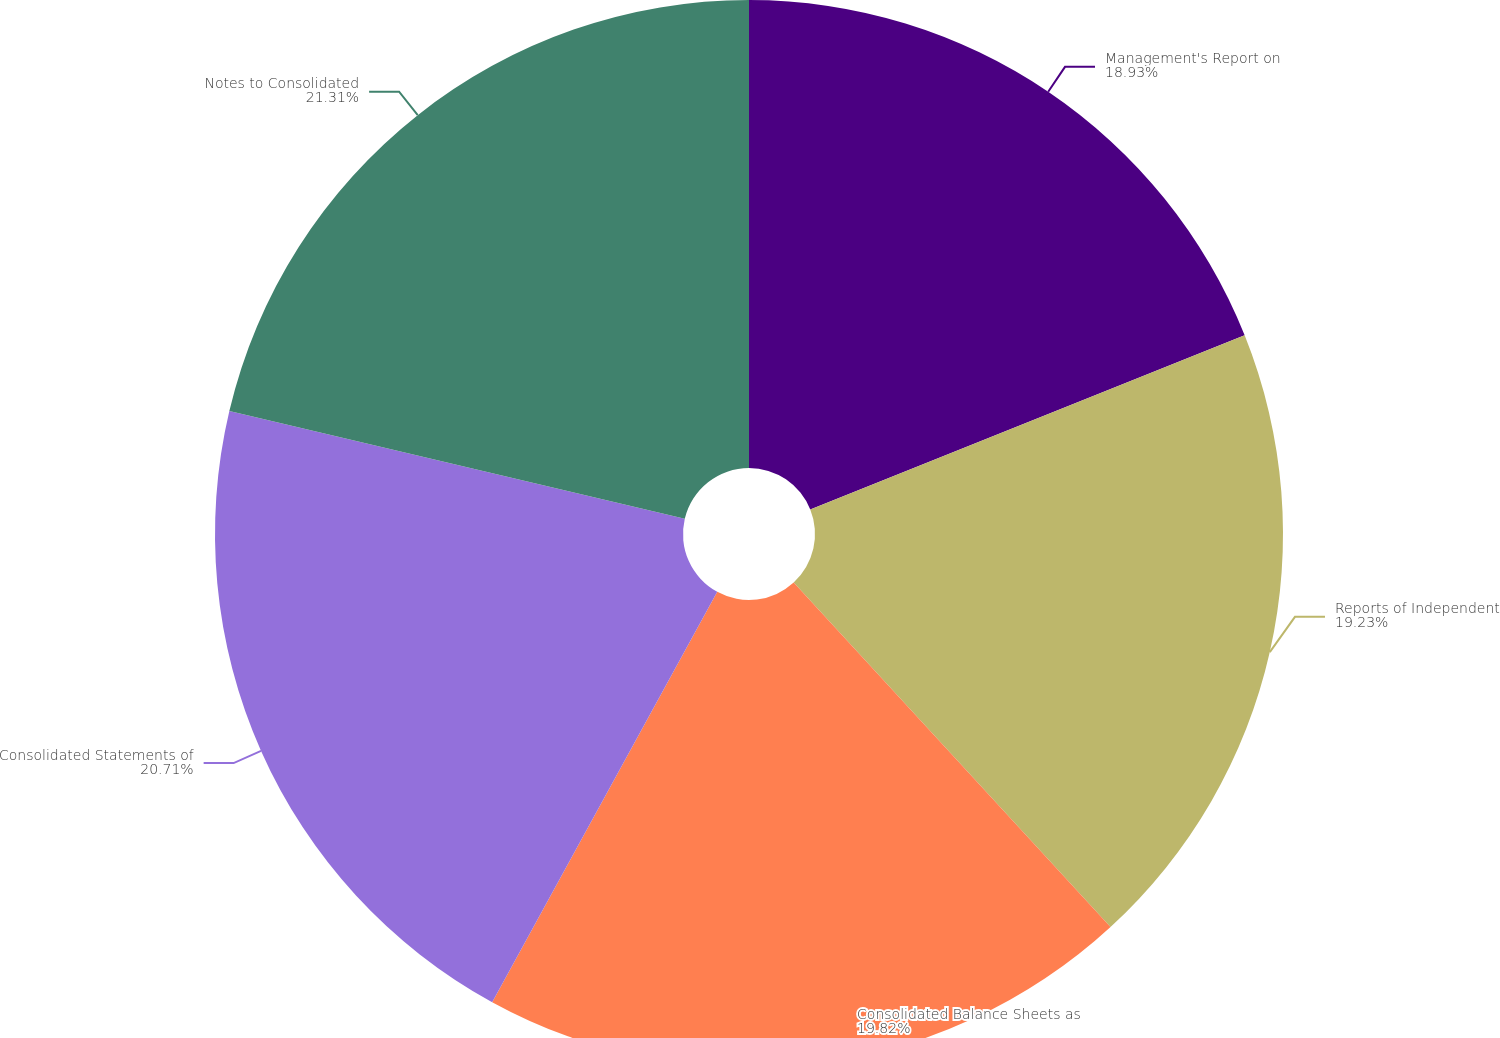Convert chart. <chart><loc_0><loc_0><loc_500><loc_500><pie_chart><fcel>Management's Report on<fcel>Reports of Independent<fcel>Consolidated Balance Sheets as<fcel>Consolidated Statements of<fcel>Notes to Consolidated<nl><fcel>18.93%<fcel>19.23%<fcel>19.82%<fcel>20.71%<fcel>21.3%<nl></chart> 